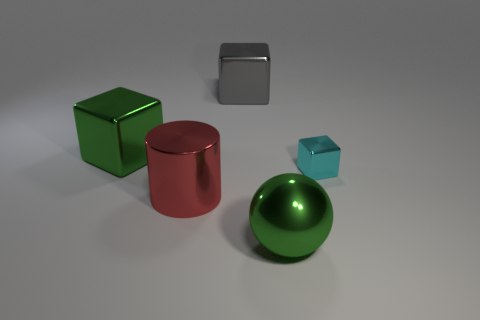What shape is the shiny thing on the right side of the green metal object that is in front of the metal cube that is on the right side of the large metal sphere?
Give a very brief answer. Cube. There is a block that is to the left of the small cyan thing and right of the large red shiny object; what color is it?
Provide a succinct answer. Gray. What is the shape of the large green metal object in front of the green shiny cube?
Provide a succinct answer. Sphere. The big red object that is the same material as the cyan thing is what shape?
Offer a very short reply. Cylinder. What number of shiny objects are small green balls or spheres?
Ensure brevity in your answer.  1. How many small cyan metal blocks are behind the green shiny object in front of the big green shiny object that is to the left of the cylinder?
Offer a very short reply. 1. Do the cyan block that is to the right of the ball and the green object behind the ball have the same size?
Offer a terse response. No. There is a tiny thing that is the same shape as the big gray thing; what is its material?
Make the answer very short. Metal. What number of large objects are cyan matte cubes or green metal balls?
Your response must be concise. 1. What is the big gray thing made of?
Provide a succinct answer. Metal. 